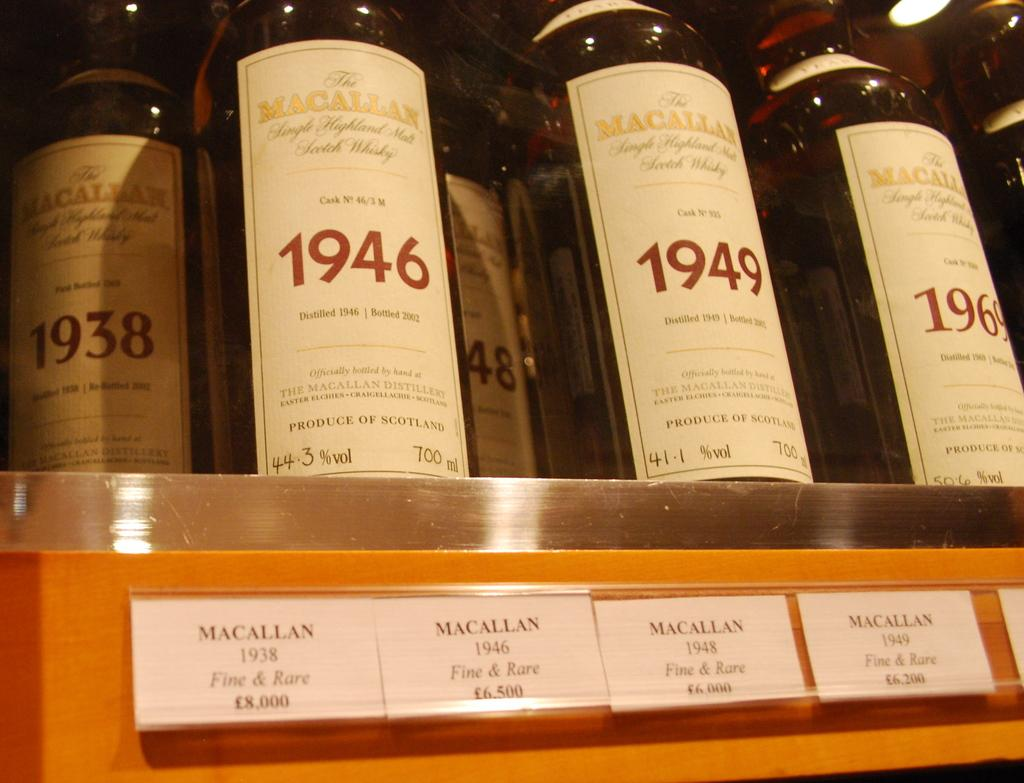<image>
Present a compact description of the photo's key features. Macallan wine bottles in a case on the shelf from the 1930s and 40s. 